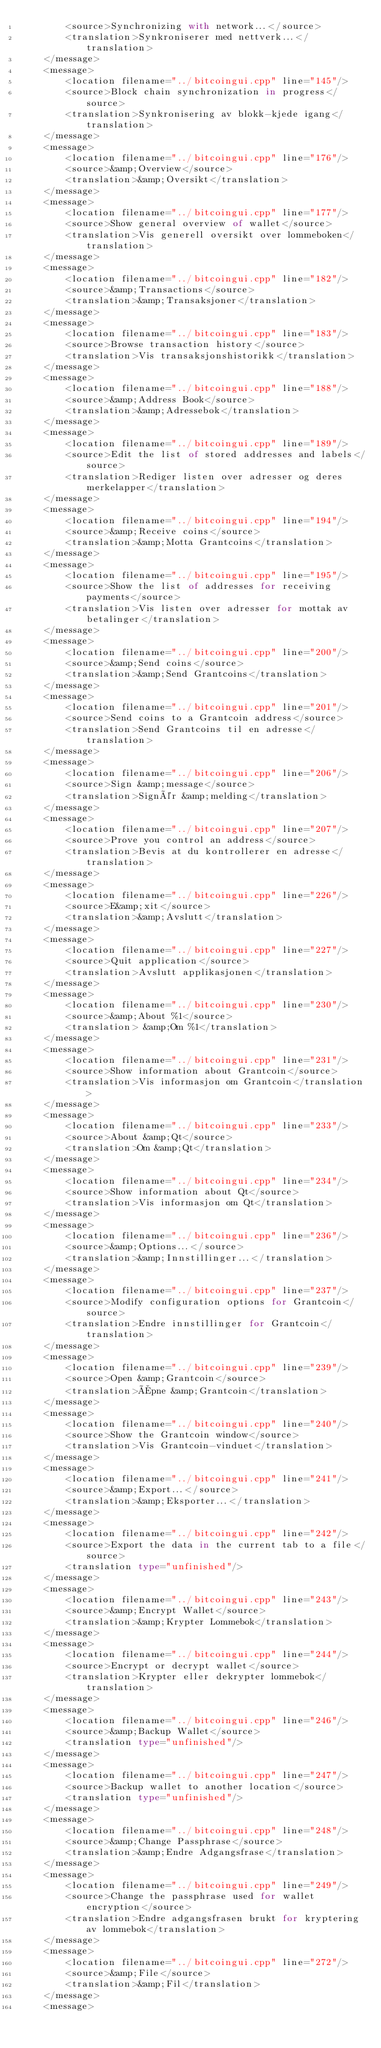Convert code to text. <code><loc_0><loc_0><loc_500><loc_500><_TypeScript_>        <source>Synchronizing with network...</source>
        <translation>Synkroniserer med nettverk...</translation>
    </message>
    <message>
        <location filename="../bitcoingui.cpp" line="145"/>
        <source>Block chain synchronization in progress</source>
        <translation>Synkronisering av blokk-kjede igang</translation>
    </message>
    <message>
        <location filename="../bitcoingui.cpp" line="176"/>
        <source>&amp;Overview</source>
        <translation>&amp;Oversikt</translation>
    </message>
    <message>
        <location filename="../bitcoingui.cpp" line="177"/>
        <source>Show general overview of wallet</source>
        <translation>Vis generell oversikt over lommeboken</translation>
    </message>
    <message>
        <location filename="../bitcoingui.cpp" line="182"/>
        <source>&amp;Transactions</source>
        <translation>&amp;Transaksjoner</translation>
    </message>
    <message>
        <location filename="../bitcoingui.cpp" line="183"/>
        <source>Browse transaction history</source>
        <translation>Vis transaksjonshistorikk</translation>
    </message>
    <message>
        <location filename="../bitcoingui.cpp" line="188"/>
        <source>&amp;Address Book</source>
        <translation>&amp;Adressebok</translation>
    </message>
    <message>
        <location filename="../bitcoingui.cpp" line="189"/>
        <source>Edit the list of stored addresses and labels</source>
        <translation>Rediger listen over adresser og deres merkelapper</translation>
    </message>
    <message>
        <location filename="../bitcoingui.cpp" line="194"/>
        <source>&amp;Receive coins</source>
        <translation>&amp;Motta Grantcoins</translation>
    </message>
    <message>
        <location filename="../bitcoingui.cpp" line="195"/>
        <source>Show the list of addresses for receiving payments</source>
        <translation>Vis listen over adresser for mottak av betalinger</translation>
    </message>
    <message>
        <location filename="../bitcoingui.cpp" line="200"/>
        <source>&amp;Send coins</source>
        <translation>&amp;Send Grantcoins</translation>
    </message>
    <message>
        <location filename="../bitcoingui.cpp" line="201"/>
        <source>Send coins to a Grantcoin address</source>
        <translation>Send Grantcoins til en adresse</translation>
    </message>
    <message>
        <location filename="../bitcoingui.cpp" line="206"/>
        <source>Sign &amp;message</source>
        <translation>Signér &amp;melding</translation>
    </message>
    <message>
        <location filename="../bitcoingui.cpp" line="207"/>
        <source>Prove you control an address</source>
        <translation>Bevis at du kontrollerer en adresse</translation>
    </message>
    <message>
        <location filename="../bitcoingui.cpp" line="226"/>
        <source>E&amp;xit</source>
        <translation>&amp;Avslutt</translation>
    </message>
    <message>
        <location filename="../bitcoingui.cpp" line="227"/>
        <source>Quit application</source>
        <translation>Avslutt applikasjonen</translation>
    </message>
    <message>
        <location filename="../bitcoingui.cpp" line="230"/>
        <source>&amp;About %1</source>
        <translation> &amp;Om %1</translation>
    </message>
    <message>
        <location filename="../bitcoingui.cpp" line="231"/>
        <source>Show information about Grantcoin</source>
        <translation>Vis informasjon om Grantcoin</translation>
    </message>
    <message>
        <location filename="../bitcoingui.cpp" line="233"/>
        <source>About &amp;Qt</source>
        <translation>Om &amp;Qt</translation>
    </message>
    <message>
        <location filename="../bitcoingui.cpp" line="234"/>
        <source>Show information about Qt</source>
        <translation>Vis informasjon om Qt</translation>
    </message>
    <message>
        <location filename="../bitcoingui.cpp" line="236"/>
        <source>&amp;Options...</source>
        <translation>&amp;Innstillinger...</translation>
    </message>
    <message>
        <location filename="../bitcoingui.cpp" line="237"/>
        <source>Modify configuration options for Grantcoin</source>
        <translation>Endre innstillinger for Grantcoin</translation>
    </message>
    <message>
        <location filename="../bitcoingui.cpp" line="239"/>
        <source>Open &amp;Grantcoin</source>
        <translation>Åpne &amp;Grantcoin</translation>
    </message>
    <message>
        <location filename="../bitcoingui.cpp" line="240"/>
        <source>Show the Grantcoin window</source>
        <translation>Vis Grantcoin-vinduet</translation>
    </message>
    <message>
        <location filename="../bitcoingui.cpp" line="241"/>
        <source>&amp;Export...</source>
        <translation>&amp;Eksporter...</translation>
    </message>
    <message>
        <location filename="../bitcoingui.cpp" line="242"/>
        <source>Export the data in the current tab to a file</source>
        <translation type="unfinished"/>
    </message>
    <message>
        <location filename="../bitcoingui.cpp" line="243"/>
        <source>&amp;Encrypt Wallet</source>
        <translation>&amp;Krypter Lommebok</translation>
    </message>
    <message>
        <location filename="../bitcoingui.cpp" line="244"/>
        <source>Encrypt or decrypt wallet</source>
        <translation>Krypter eller dekrypter lommebok</translation>
    </message>
    <message>
        <location filename="../bitcoingui.cpp" line="246"/>
        <source>&amp;Backup Wallet</source>
        <translation type="unfinished"/>
    </message>
    <message>
        <location filename="../bitcoingui.cpp" line="247"/>
        <source>Backup wallet to another location</source>
        <translation type="unfinished"/>
    </message>
    <message>
        <location filename="../bitcoingui.cpp" line="248"/>
        <source>&amp;Change Passphrase</source>
        <translation>&amp;Endre Adgangsfrase</translation>
    </message>
    <message>
        <location filename="../bitcoingui.cpp" line="249"/>
        <source>Change the passphrase used for wallet encryption</source>
        <translation>Endre adgangsfrasen brukt for kryptering av lommebok</translation>
    </message>
    <message>
        <location filename="../bitcoingui.cpp" line="272"/>
        <source>&amp;File</source>
        <translation>&amp;Fil</translation>
    </message>
    <message></code> 